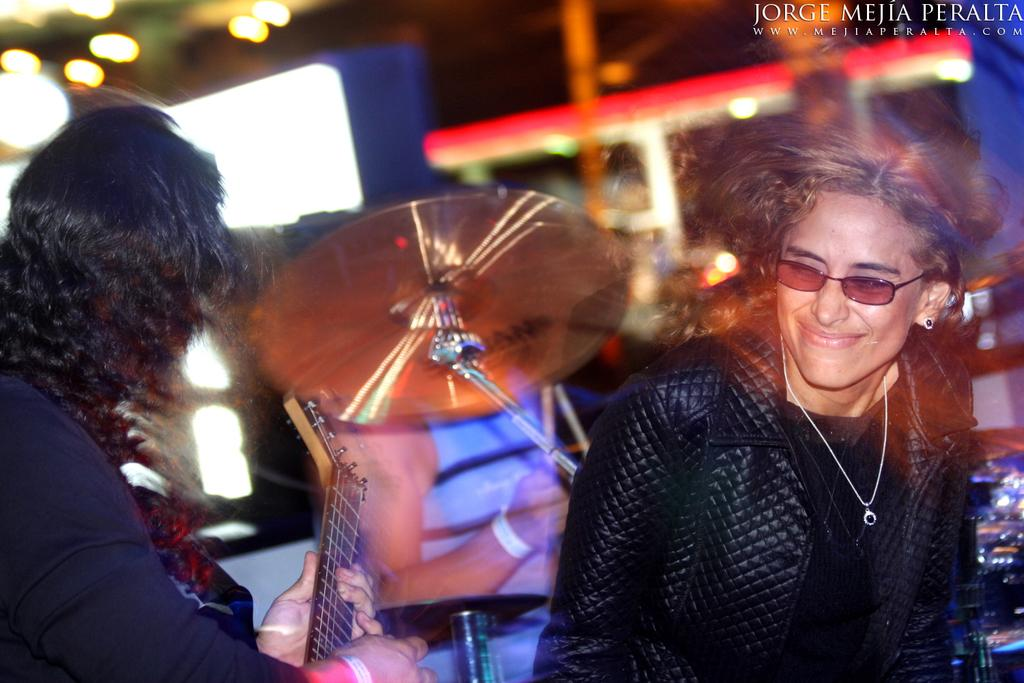What is happening in the image? There is a group of people in the image, with a person playing a guitar on the left side, a person playing drums at the center, and a person laughing on the right side. What instruments are being played in the image? A guitar and drums are being played in the image. How are the people in the image interacting with each other? The person playing the guitar and the person playing the drums are likely playing music together, while the person laughing on the right side may be enjoying the performance. What type of linen is draped over the coach in the image? There is no coach or linen present in the image. What sound does the bell make in the image? There is no bell present in the image. 